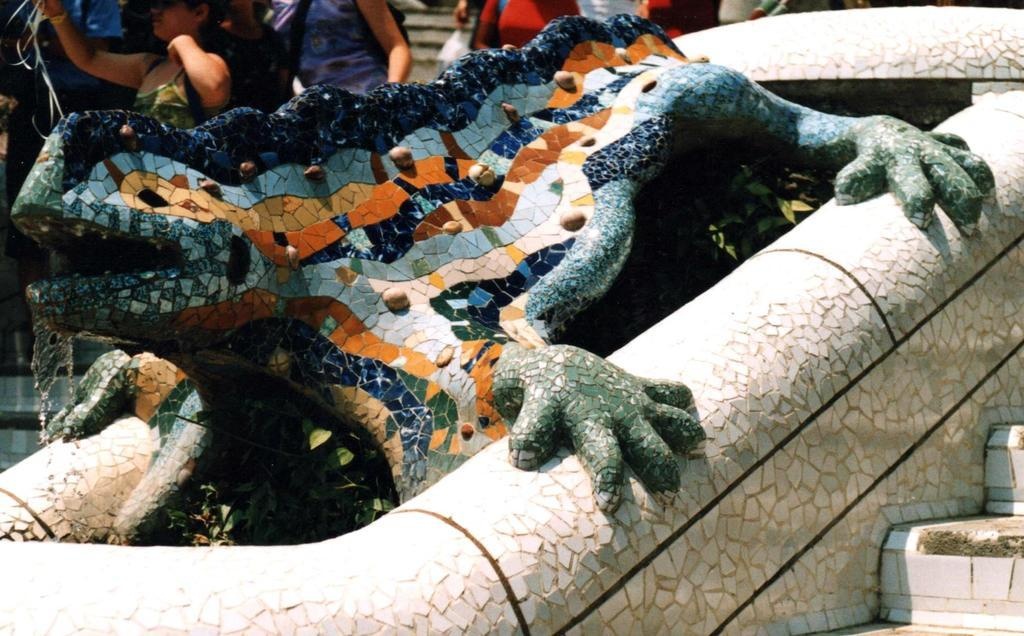What type of statue is in the image? There is a stone and ceramic lizard statue in the image. Where is the statue located in the image? The statue is placed in the front bottom side of the image. What are the girls in the background of the image doing? The girls are taking photographs. Can you see any boats or planes in the image? No, there are no boats or planes present in the image. 